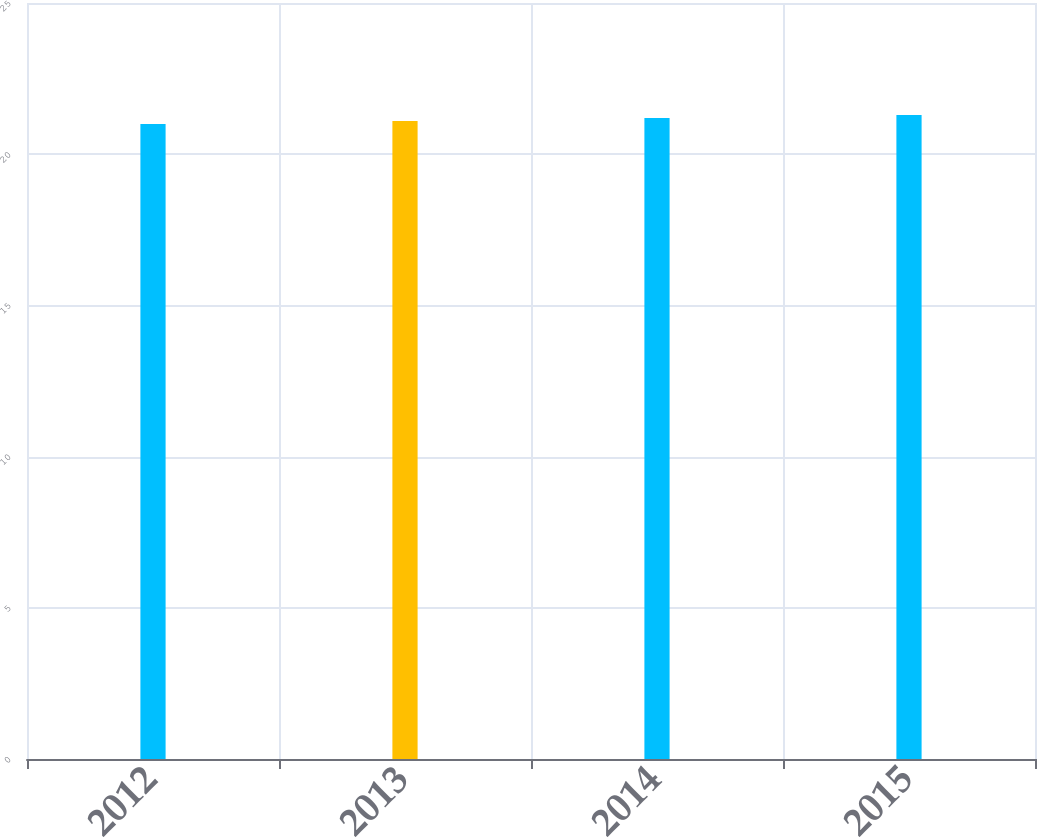Convert chart to OTSL. <chart><loc_0><loc_0><loc_500><loc_500><bar_chart><fcel>2012<fcel>2013<fcel>2014<fcel>2015<nl><fcel>21<fcel>21.1<fcel>21.2<fcel>21.3<nl></chart> 